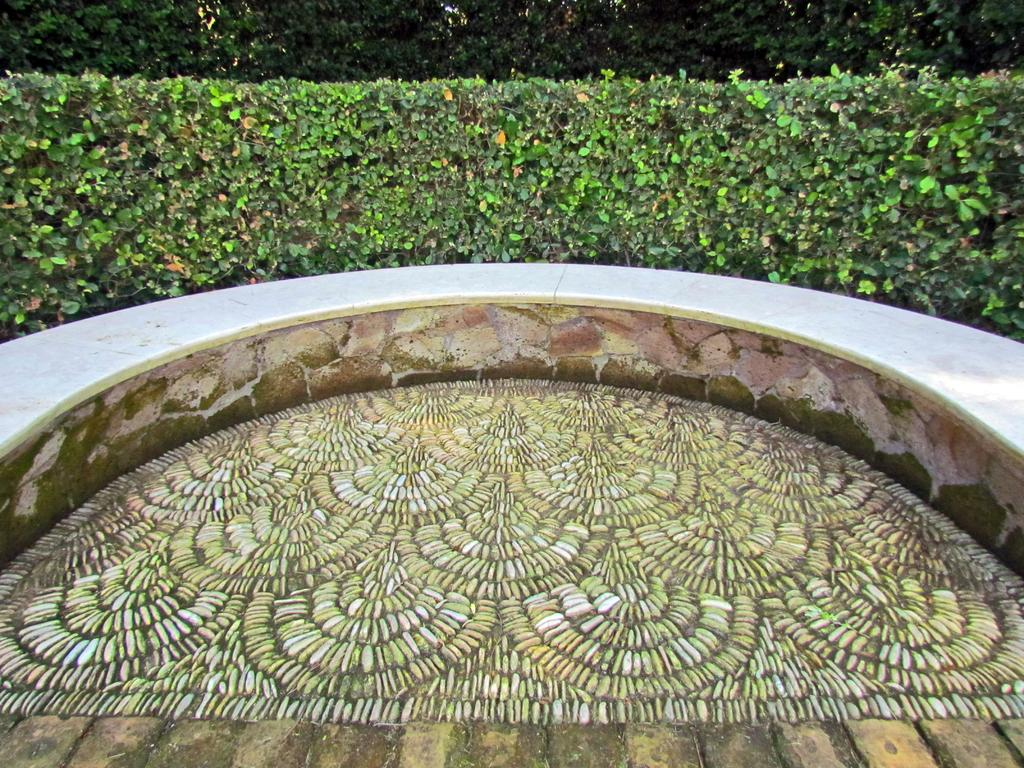What type of design can be seen on the floor in the image? There is a floor with a design in the image. What surrounds the floor in the image? There is a circular wall around the floor. What can be seen in the background of the image? There are plants in the background of the image. Is there a driving offer available for the plants in the background of the image? There is no mention of driving or offers in the image; it features a floor with a design, a circular wall, and plants in the background. 